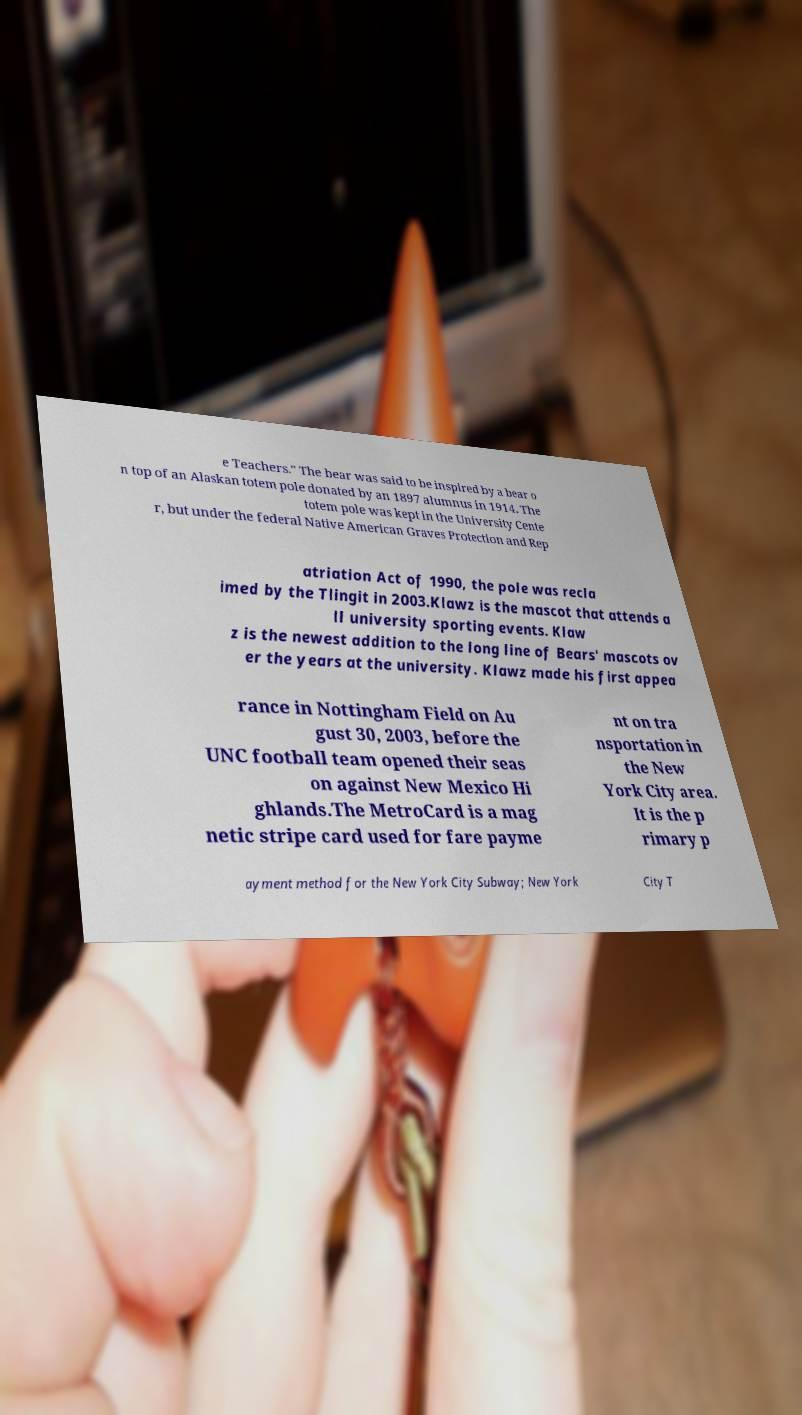For documentation purposes, I need the text within this image transcribed. Could you provide that? e Teachers." The bear was said to be inspired by a bear o n top of an Alaskan totem pole donated by an 1897 alumnus in 1914. The totem pole was kept in the University Cente r, but under the federal Native American Graves Protection and Rep atriation Act of 1990, the pole was recla imed by the Tlingit in 2003.Klawz is the mascot that attends a ll university sporting events. Klaw z is the newest addition to the long line of Bears' mascots ov er the years at the university. Klawz made his first appea rance in Nottingham Field on Au gust 30, 2003, before the UNC football team opened their seas on against New Mexico Hi ghlands.The MetroCard is a mag netic stripe card used for fare payme nt on tra nsportation in the New York City area. It is the p rimary p ayment method for the New York City Subway; New York City T 